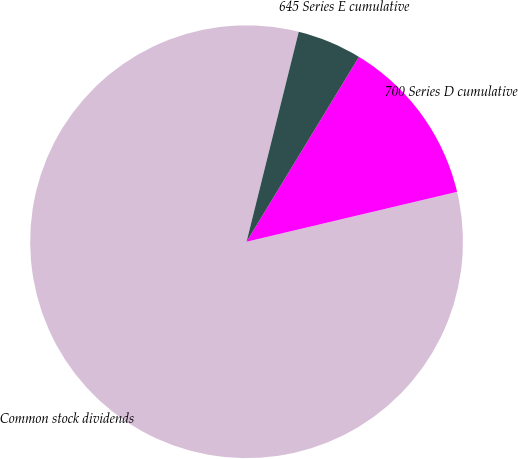Convert chart to OTSL. <chart><loc_0><loc_0><loc_500><loc_500><pie_chart><fcel>Common stock dividends<fcel>700 Series D cumulative<fcel>645 Series E cumulative<nl><fcel>82.58%<fcel>12.6%<fcel>4.82%<nl></chart> 